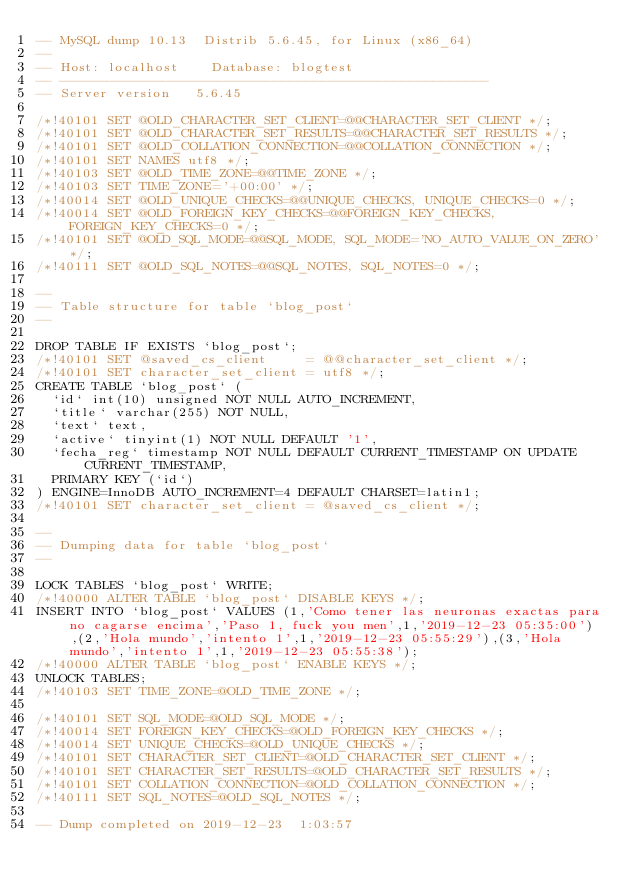Convert code to text. <code><loc_0><loc_0><loc_500><loc_500><_SQL_>-- MySQL dump 10.13  Distrib 5.6.45, for Linux (x86_64)
--
-- Host: localhost    Database: blogtest
-- ------------------------------------------------------
-- Server version	5.6.45

/*!40101 SET @OLD_CHARACTER_SET_CLIENT=@@CHARACTER_SET_CLIENT */;
/*!40101 SET @OLD_CHARACTER_SET_RESULTS=@@CHARACTER_SET_RESULTS */;
/*!40101 SET @OLD_COLLATION_CONNECTION=@@COLLATION_CONNECTION */;
/*!40101 SET NAMES utf8 */;
/*!40103 SET @OLD_TIME_ZONE=@@TIME_ZONE */;
/*!40103 SET TIME_ZONE='+00:00' */;
/*!40014 SET @OLD_UNIQUE_CHECKS=@@UNIQUE_CHECKS, UNIQUE_CHECKS=0 */;
/*!40014 SET @OLD_FOREIGN_KEY_CHECKS=@@FOREIGN_KEY_CHECKS, FOREIGN_KEY_CHECKS=0 */;
/*!40101 SET @OLD_SQL_MODE=@@SQL_MODE, SQL_MODE='NO_AUTO_VALUE_ON_ZERO' */;
/*!40111 SET @OLD_SQL_NOTES=@@SQL_NOTES, SQL_NOTES=0 */;

--
-- Table structure for table `blog_post`
--

DROP TABLE IF EXISTS `blog_post`;
/*!40101 SET @saved_cs_client     = @@character_set_client */;
/*!40101 SET character_set_client = utf8 */;
CREATE TABLE `blog_post` (
  `id` int(10) unsigned NOT NULL AUTO_INCREMENT,
  `title` varchar(255) NOT NULL,
  `text` text,
  `active` tinyint(1) NOT NULL DEFAULT '1',
  `fecha_reg` timestamp NOT NULL DEFAULT CURRENT_TIMESTAMP ON UPDATE CURRENT_TIMESTAMP,
  PRIMARY KEY (`id`)
) ENGINE=InnoDB AUTO_INCREMENT=4 DEFAULT CHARSET=latin1;
/*!40101 SET character_set_client = @saved_cs_client */;

--
-- Dumping data for table `blog_post`
--

LOCK TABLES `blog_post` WRITE;
/*!40000 ALTER TABLE `blog_post` DISABLE KEYS */;
INSERT INTO `blog_post` VALUES (1,'Como tener las neuronas exactas para no cagarse encima','Paso 1, fuck you men',1,'2019-12-23 05:35:00'),(2,'Hola mundo','intento 1',1,'2019-12-23 05:55:29'),(3,'Hola mundo','intento 1',1,'2019-12-23 05:55:38');
/*!40000 ALTER TABLE `blog_post` ENABLE KEYS */;
UNLOCK TABLES;
/*!40103 SET TIME_ZONE=@OLD_TIME_ZONE */;

/*!40101 SET SQL_MODE=@OLD_SQL_MODE */;
/*!40014 SET FOREIGN_KEY_CHECKS=@OLD_FOREIGN_KEY_CHECKS */;
/*!40014 SET UNIQUE_CHECKS=@OLD_UNIQUE_CHECKS */;
/*!40101 SET CHARACTER_SET_CLIENT=@OLD_CHARACTER_SET_CLIENT */;
/*!40101 SET CHARACTER_SET_RESULTS=@OLD_CHARACTER_SET_RESULTS */;
/*!40101 SET COLLATION_CONNECTION=@OLD_COLLATION_CONNECTION */;
/*!40111 SET SQL_NOTES=@OLD_SQL_NOTES */;

-- Dump completed on 2019-12-23  1:03:57
</code> 